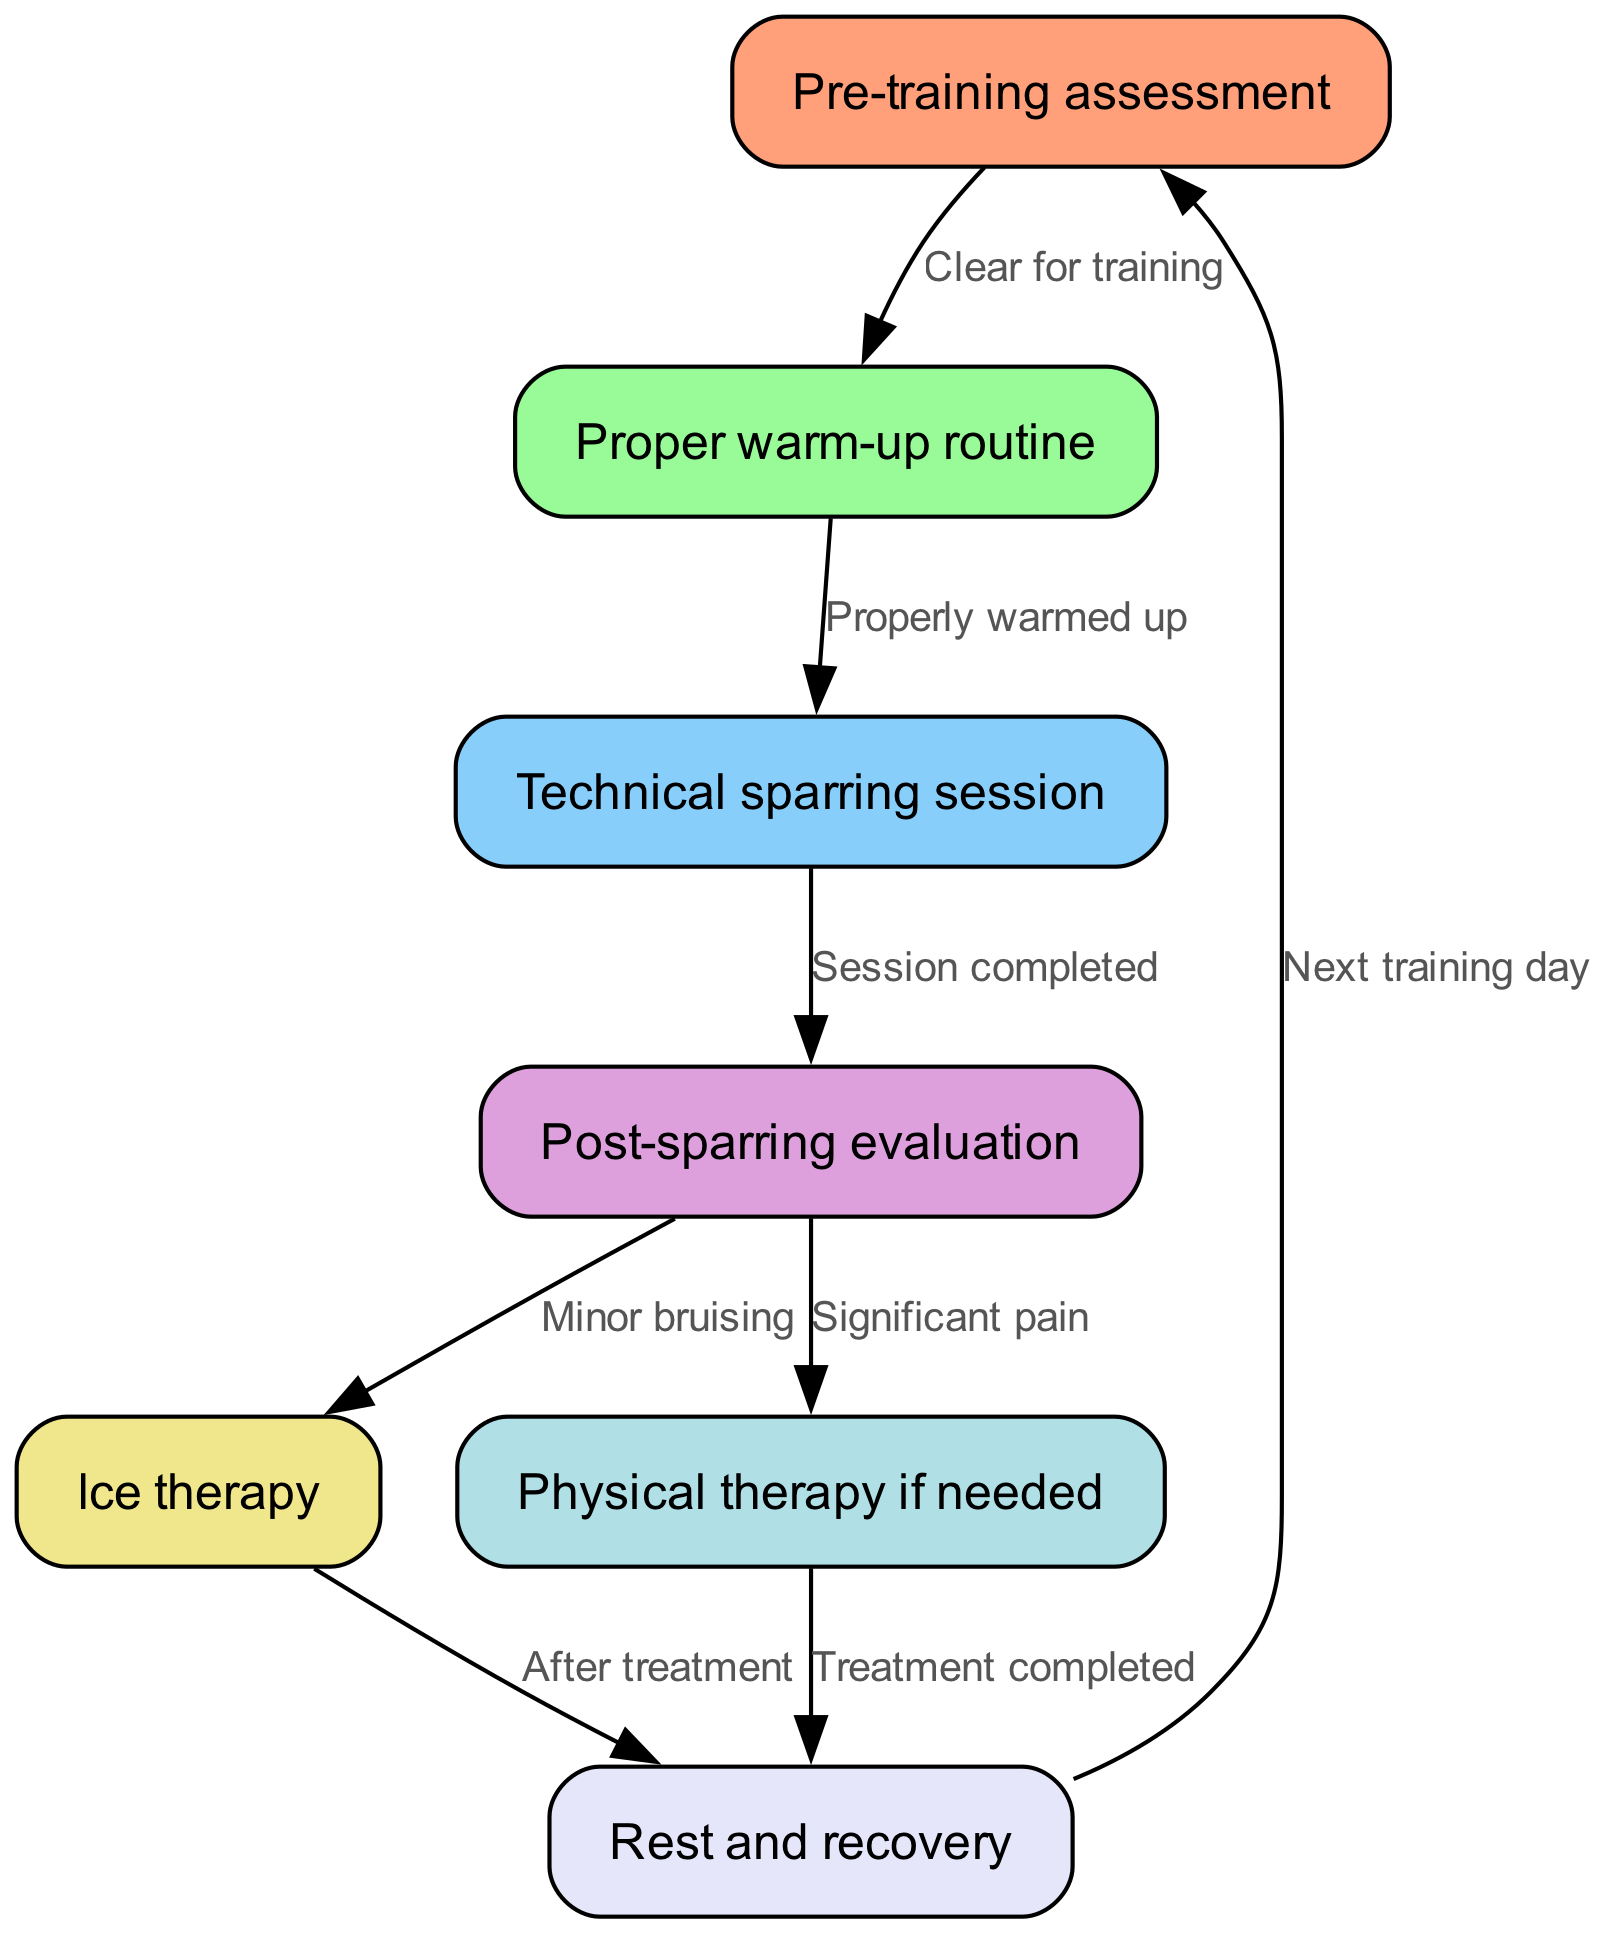What is the first step in the protocol? The first step in the protocol is stated as "Pre-training assessment." This is represented as the starting node in the diagram, indicating that it’s the initial action before any training or sparring takes place.
Answer: Pre-training assessment What is the last step before the next training day? The last step before the next training day shown in the flow chart is "Rest and recovery." This node is connected to the first step once again, indicating the cycle is complete.
Answer: Rest and recovery How many edges are there in total? By counting the connections between nodes (edges), we find that there are 8 distinct edges connecting the various parts of the protocol. Each edge represents a relationship or direction of flow from one step to another.
Answer: 8 What action is taken after minor bruising is noted? After minor bruising is noted, the next action in the protocol is "Ice therapy." This follows logically in the steps outlined in the diagram, indicating treatment for bruising.
Answer: Ice therapy What happens if significant pain is noted after the sparring session? If significant pain is noted after the sparring session, the protocol calls for "Physical therapy if needed." This indicates a more serious concern requiring intervention.
Answer: Physical therapy if needed What is the relationship between "Post-sparring evaluation" and "Ice therapy"? The relationship is that "Post-sparring evaluation" leads to "Ice therapy" with the implication of "Minor bruising." This means that when bruises occur during sparring, ice therapy is the next recommended step in recovery.
Answer: Minor bruising How does one proceed after completing treatment in physical therapy? After completing treatment in physical therapy, the next step would be "Rest and recovery." This indicates a necessary period for the body to recover post-therapy before resuming training.
Answer: Rest and recovery What connects "Technical sparring session" to "Post-sparring evaluation"? The connection is represented by the edge labeled "Session completed." This signifies that once a sparring session ends, the evaluation is the immediate follow-up step in the protocol.
Answer: Session completed 